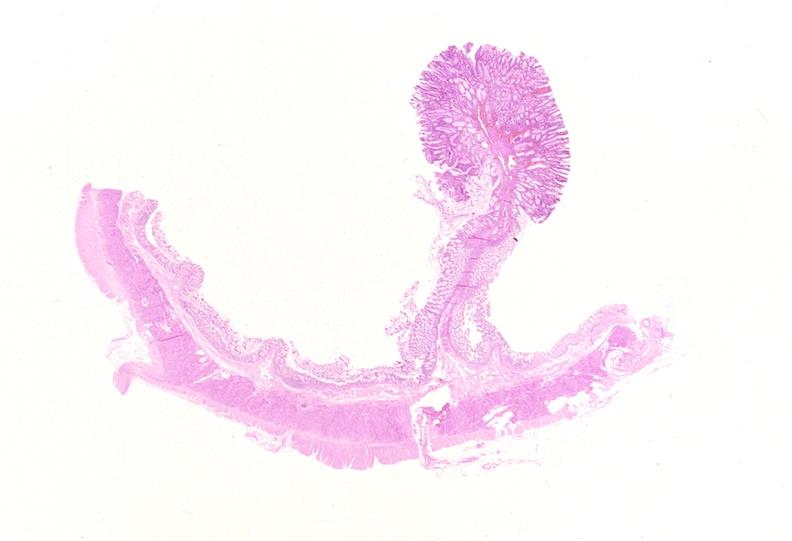s endometritis present?
Answer the question using a single word or phrase. No 